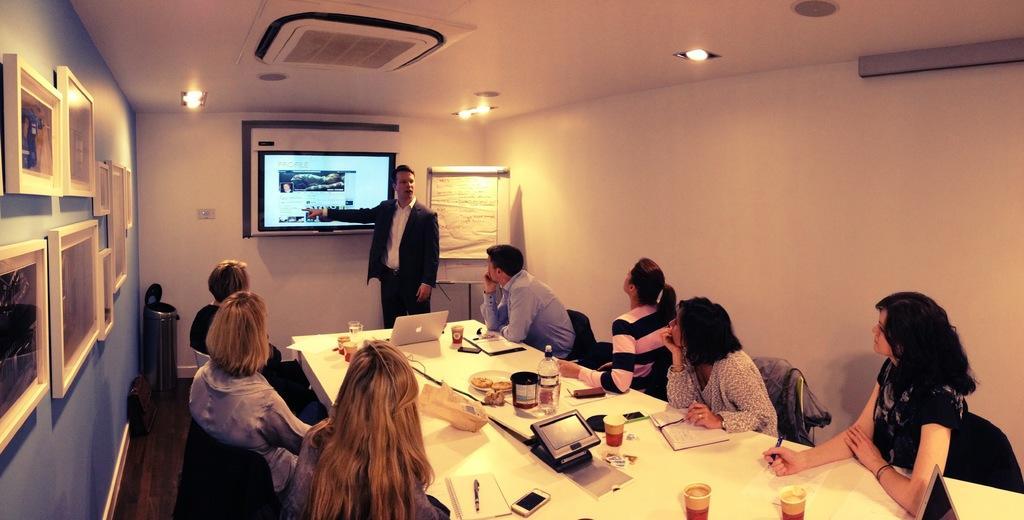Describe this image in one or two sentences. In this image there are a few people sitting on the chair, in the middle of them there is a table with the laptop, plate, mobile, books, pens, glasses and other objects on top of it. A few are holding pens in their hands. On the right side of the image there are a few frames hanging on the wall and there is a dustbin and a bag on the floor. In the background there is a screen hanging on the wall, beside that there is a board. At the top of the image there is a ceiling with the lights, in front of the screen there is a person standing. 